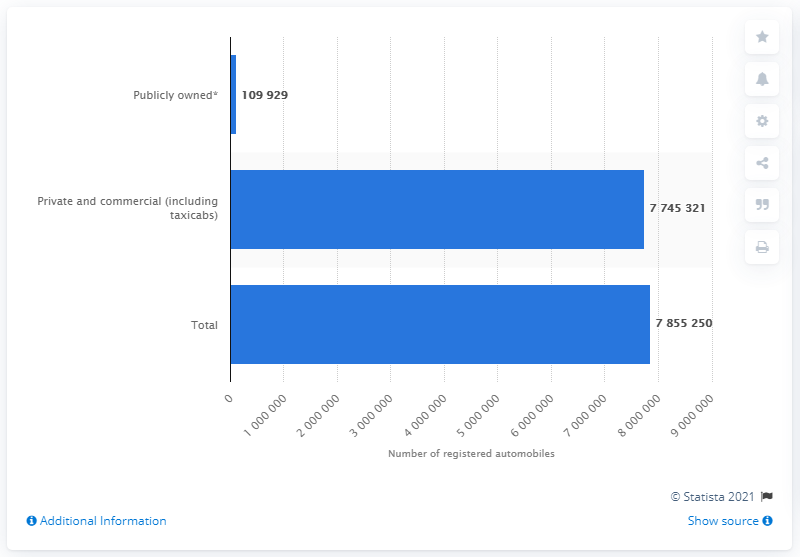Highlight a few significant elements in this photo. In the year 2016, there were a total of 7,745,321 privately and commercially registered automobiles in the state of Florida. 